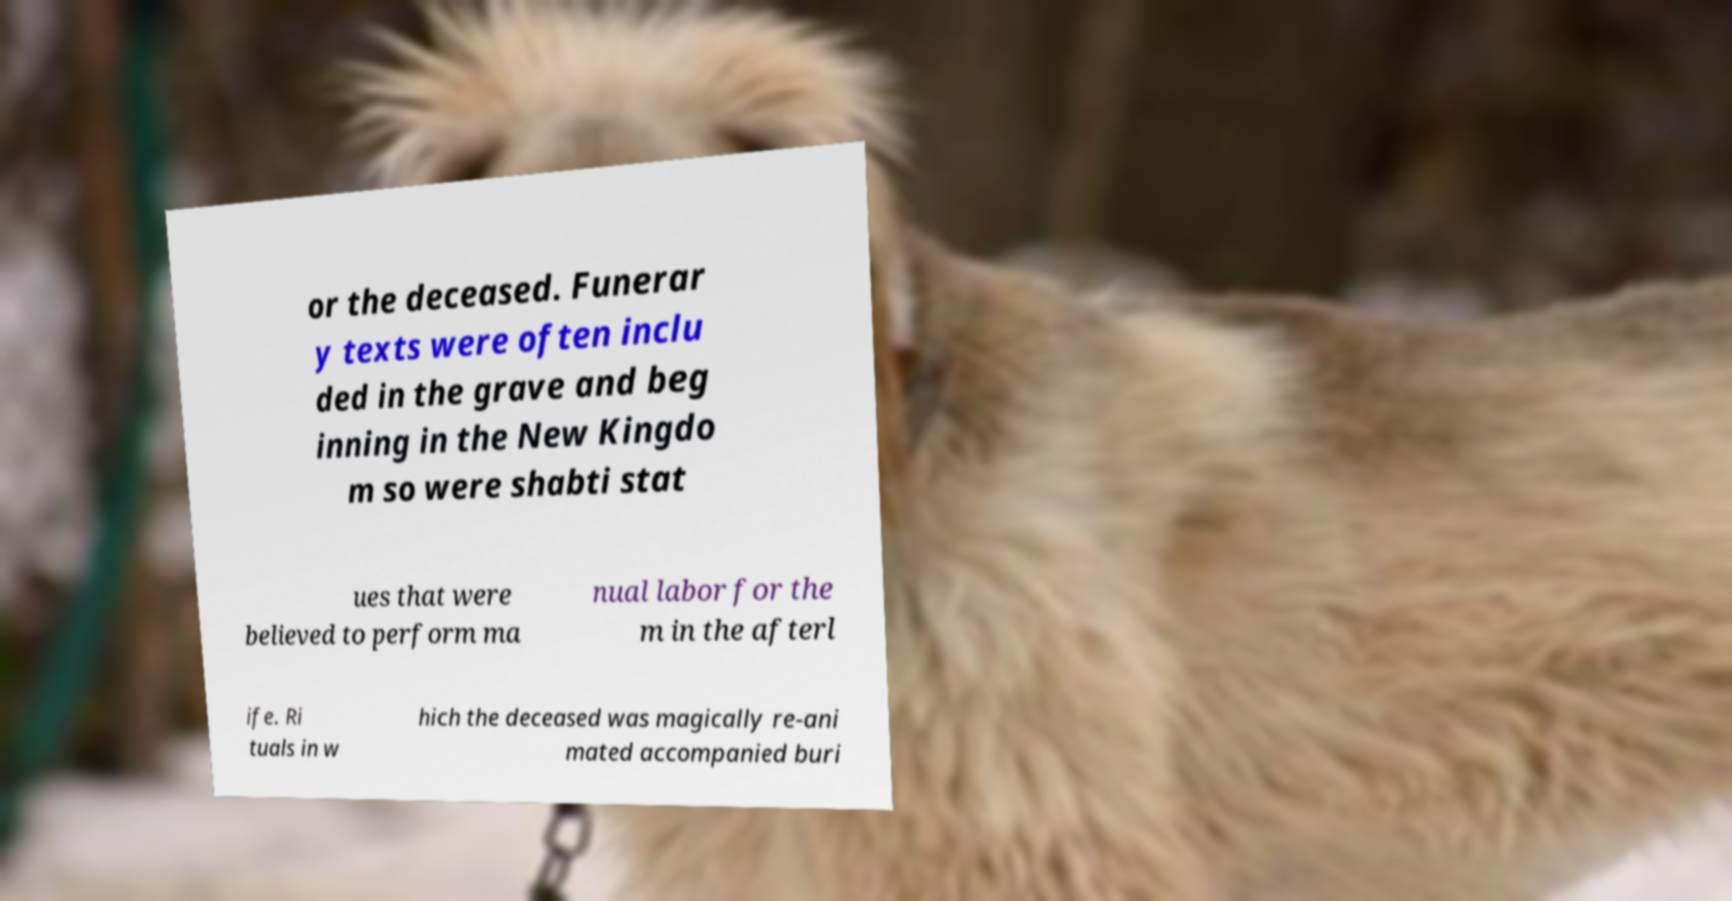I need the written content from this picture converted into text. Can you do that? or the deceased. Funerar y texts were often inclu ded in the grave and beg inning in the New Kingdo m so were shabti stat ues that were believed to perform ma nual labor for the m in the afterl ife. Ri tuals in w hich the deceased was magically re-ani mated accompanied buri 